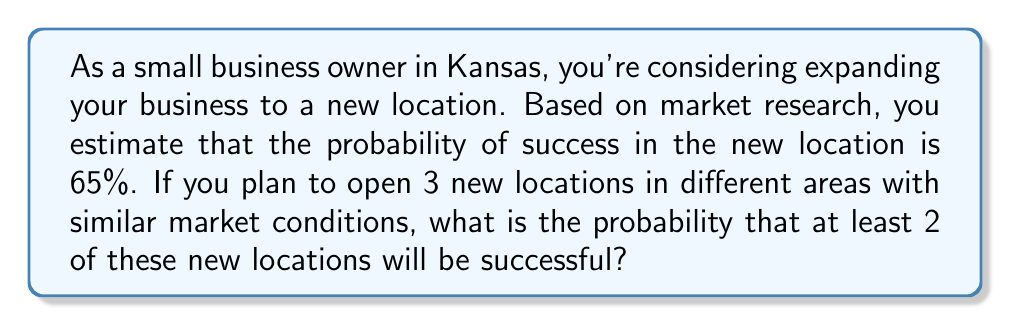Can you solve this math problem? To solve this problem, we'll use the binomial probability distribution. Let's break it down step-by-step:

1) First, let's define our variables:
   $n = 3$ (number of new locations)
   $p = 0.65$ (probability of success for each location)
   $q = 1 - p = 0.35$ (probability of failure for each location)

2) We want the probability of at least 2 successes out of 3 attempts. This can be calculated as:
   P(at least 2 successes) = P(2 successes) + P(3 successes)

3) The binomial probability formula is:
   $$P(X = k) = \binom{n}{k} p^k q^{n-k}$$
   where $\binom{n}{k}$ is the binomial coefficient.

4) For 2 successes:
   $$P(X = 2) = \binom{3}{2} (0.65)^2 (0.35)^1$$
   $$= 3 \cdot 0.65^2 \cdot 0.35 = 3 \cdot 0.4225 \cdot 0.35 = 0.44363$$

5) For 3 successes:
   $$P(X = 3) = \binom{3}{3} (0.65)^3 (0.35)^0$$
   $$= 1 \cdot 0.65^3 = 0.274625$$

6) The total probability is the sum of these two probabilities:
   P(at least 2 successes) = 0.44363 + 0.274625 = 0.718255

Therefore, the probability of at least 2 out of 3 new locations being successful is approximately 0.718255 or 71.83%.
Answer: 0.718255 or 71.83% 